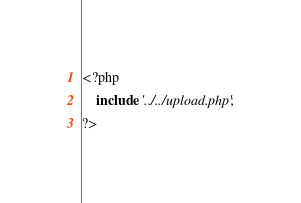Convert code to text. <code><loc_0><loc_0><loc_500><loc_500><_PHP_><?php
    include '../../upload.php';
?></code> 